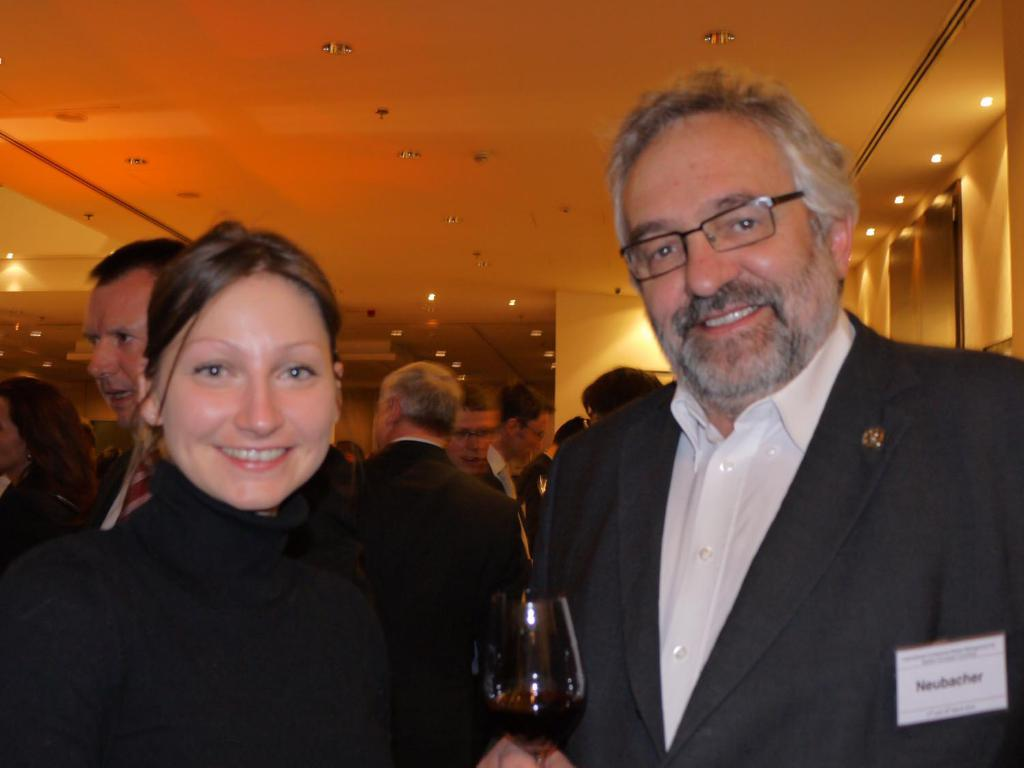Who are the two people in the center of the image? There is a man and a woman in the center of the image. What are the man and woman holding in their hands? The man and woman are holding glass tumblers. Can you describe the background of the image? There are persons in the background of the image, along with lights and a wall. What news did the man and woman receive from their friends in the image? There is no mention of news or friends in the image; it only shows the man and woman holding glass tumblers and the background. 